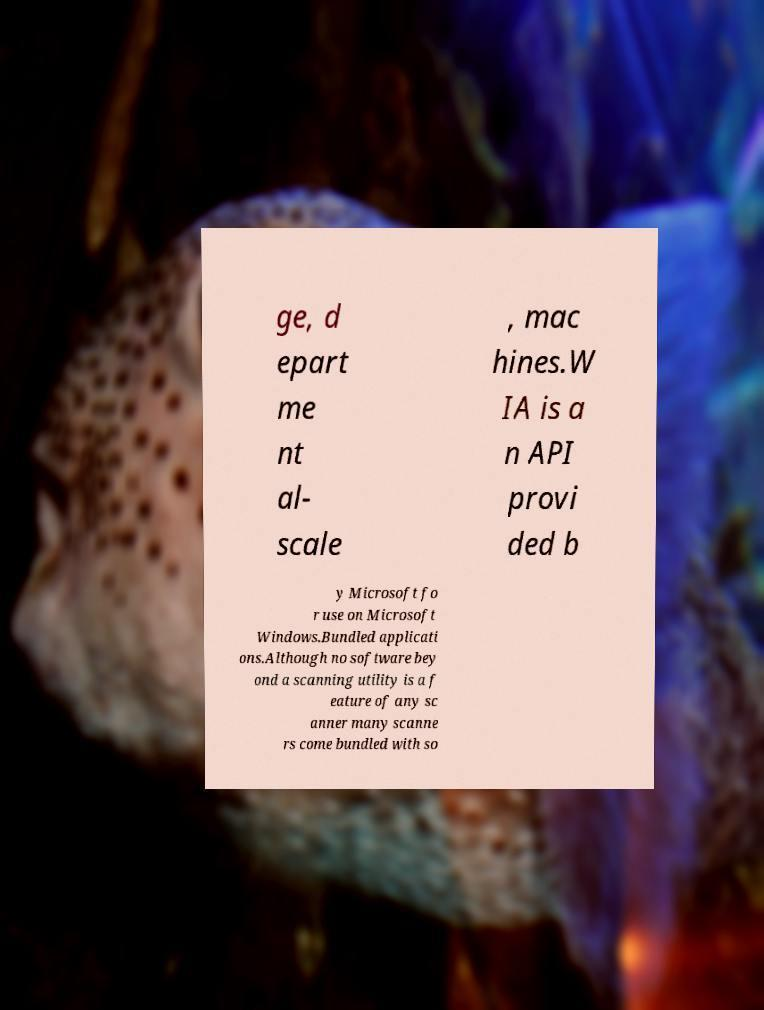Could you assist in decoding the text presented in this image and type it out clearly? ge, d epart me nt al- scale , mac hines.W IA is a n API provi ded b y Microsoft fo r use on Microsoft Windows.Bundled applicati ons.Although no software bey ond a scanning utility is a f eature of any sc anner many scanne rs come bundled with so 